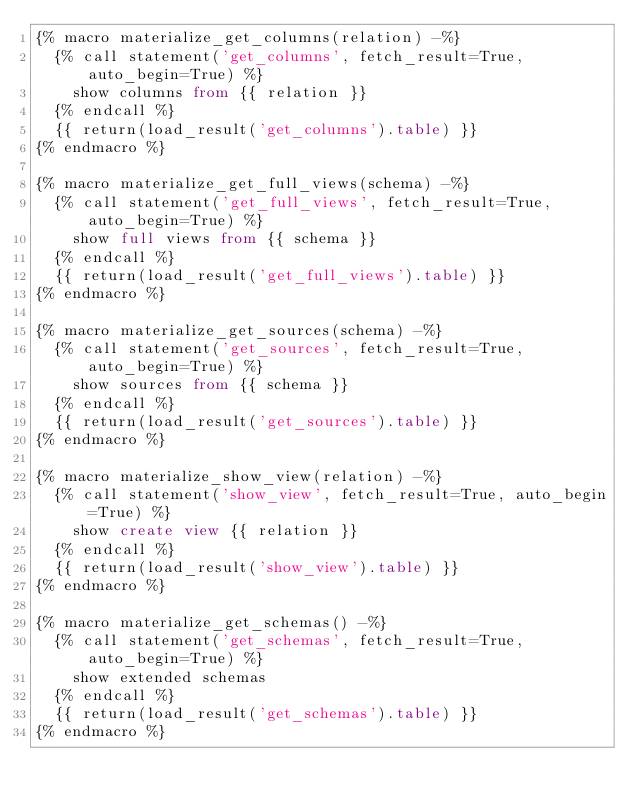<code> <loc_0><loc_0><loc_500><loc_500><_SQL_>{% macro materialize_get_columns(relation) -%}
  {% call statement('get_columns', fetch_result=True, auto_begin=True) %}
    show columns from {{ relation }}
  {% endcall %}
  {{ return(load_result('get_columns').table) }}
{% endmacro %}

{% macro materialize_get_full_views(schema) -%}
  {% call statement('get_full_views', fetch_result=True, auto_begin=True) %}
    show full views from {{ schema }}
  {% endcall %}
  {{ return(load_result('get_full_views').table) }}
{% endmacro %}

{% macro materialize_get_sources(schema) -%}
  {% call statement('get_sources', fetch_result=True, auto_begin=True) %}
    show sources from {{ schema }}
  {% endcall %}
  {{ return(load_result('get_sources').table) }}
{% endmacro %}

{% macro materialize_show_view(relation) -%}
  {% call statement('show_view', fetch_result=True, auto_begin=True) %}
    show create view {{ relation }}
  {% endcall %}
  {{ return(load_result('show_view').table) }}
{% endmacro %}

{% macro materialize_get_schemas() -%}
  {% call statement('get_schemas', fetch_result=True, auto_begin=True) %}
    show extended schemas
  {% endcall %}
  {{ return(load_result('get_schemas').table) }}
{% endmacro %}
</code> 